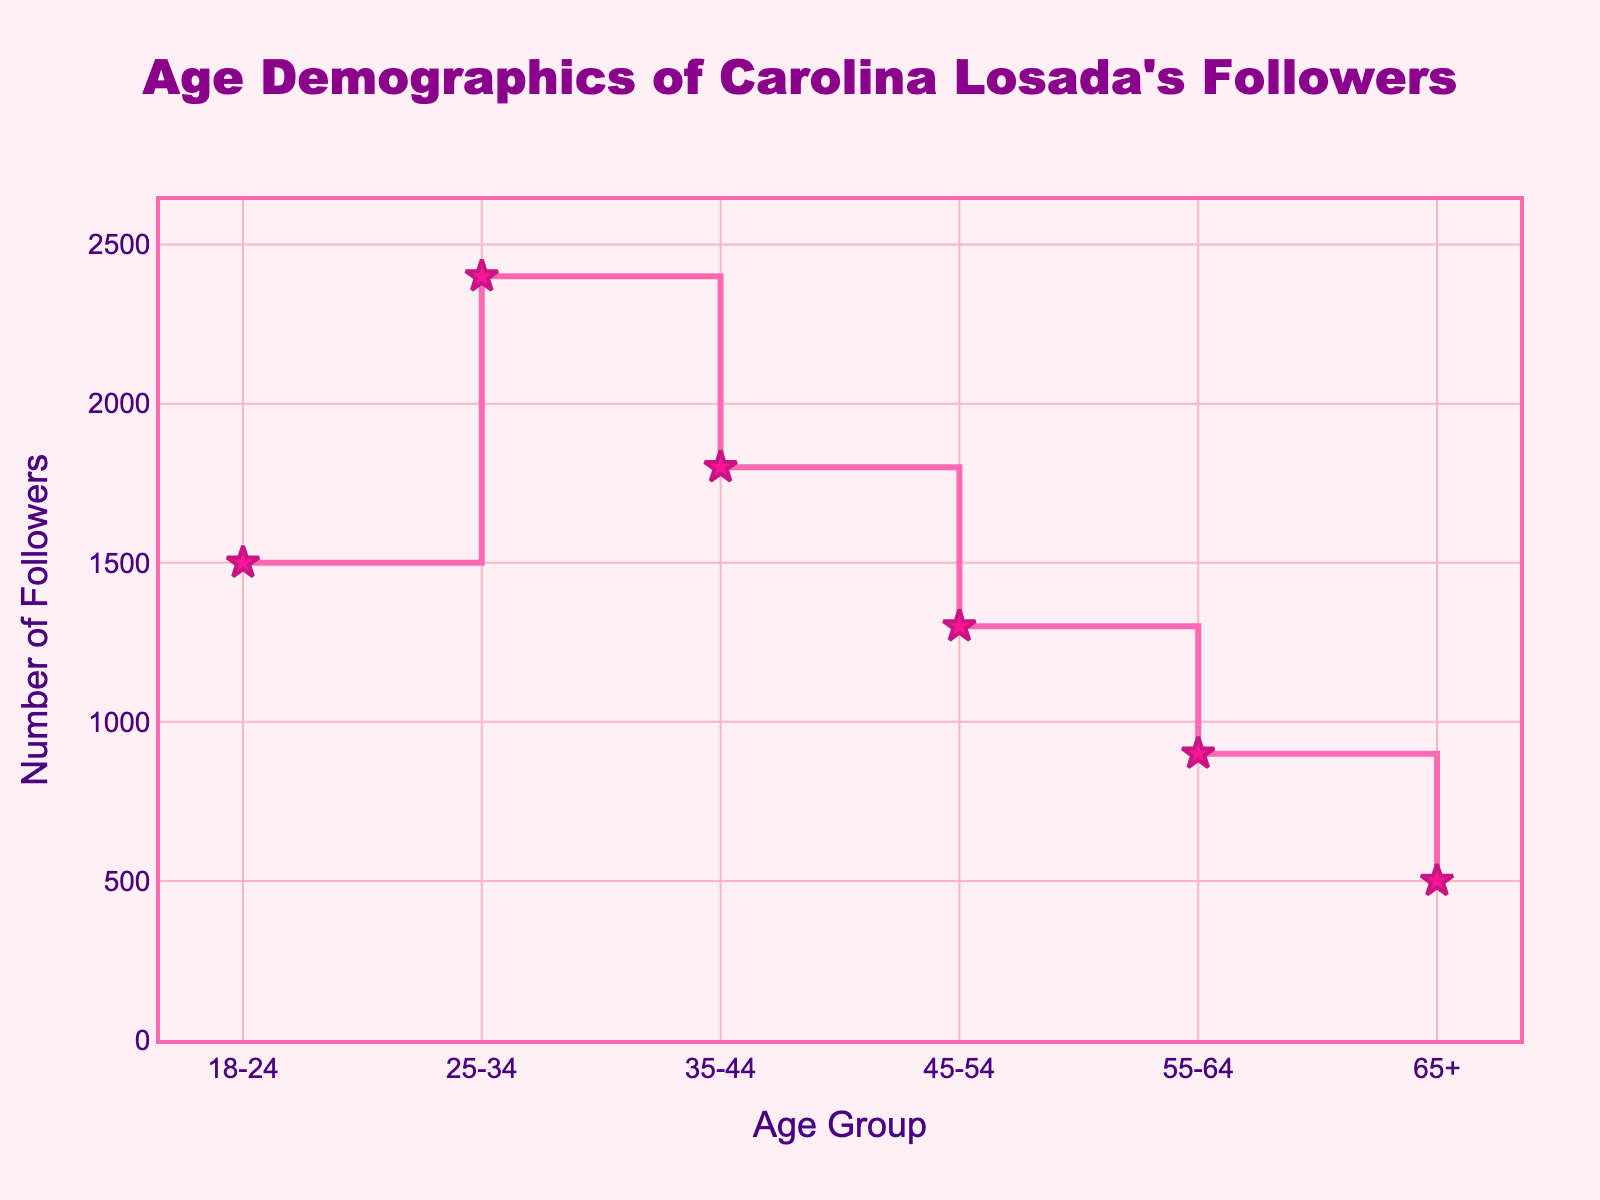What's the title of the figure? The title of the figure is typically displayed at the top and is usually in a larger and distinctive font to grab attention. In this figure, it reads "Age Demographics of Carolina Losada's Followers". This can be easily spotted and read from the top section of the plot.
Answer: Age Demographics of Carolina Losada's Followers Which age group has the highest number of followers? To identify this, we can look at the y-values corresponding to each age group. The highest point on the y-axis gives the corresponding age group. Here, the age group 25-34 has the highest number of followers with a count of 2400.
Answer: 25-34 What is the number of followers in the age group 55-64? By examining the stair plot, we locate the point corresponding to the age group 55-64 on the x-axis and then see where it touches the y-axis. In this case, it shows 900 followers.
Answer: 900 How many followers are there in the age group 65+? Checking the plot for the age group 65+ on the x-axis, we observe the corresponding y-value. This reveals that there are 500 followers in the age group 65+.
Answer: 500 What is the difference in the number of followers between the age groups 18-24 and 45-54? The number of followers in the age group 18-24 is 1500 and in 45-54 is 1300. Subtracting 1300 from 1500 gives us the difference. So, 1500 - 1300 = 200.
Answer: 200 Which two consecutive age groups show the biggest decrease in the number of followers? We need to examine the differences between the y-values for each consecutive age group. Calculating these, we find that the largest drop is between the age groups 35-44 (1800 followers) and 45-54 (1300 followers), which is 500 followers.
Answer: 35-44 and 45-54 What's the total number of followers for all the age groups combined? Summing up the followers from each age group: 1500 + 2400 + 1800 + 1300 + 900 + 500, the total is 8400 followers.
Answer: 8400 What is the average number of followers per age group? The total number of followers is 8400. There are 6 age groups. Dividing the total number by the count of age groups: 8400 / 6 = 1400.
Answer: 1400 What is the shape of the line connecting the data points on the plot? The line shape is described as 'hv', indicating that it follows a stair-like pattern, with horizontal and vertical lines connecting the data points on each step.
Answer: hv 